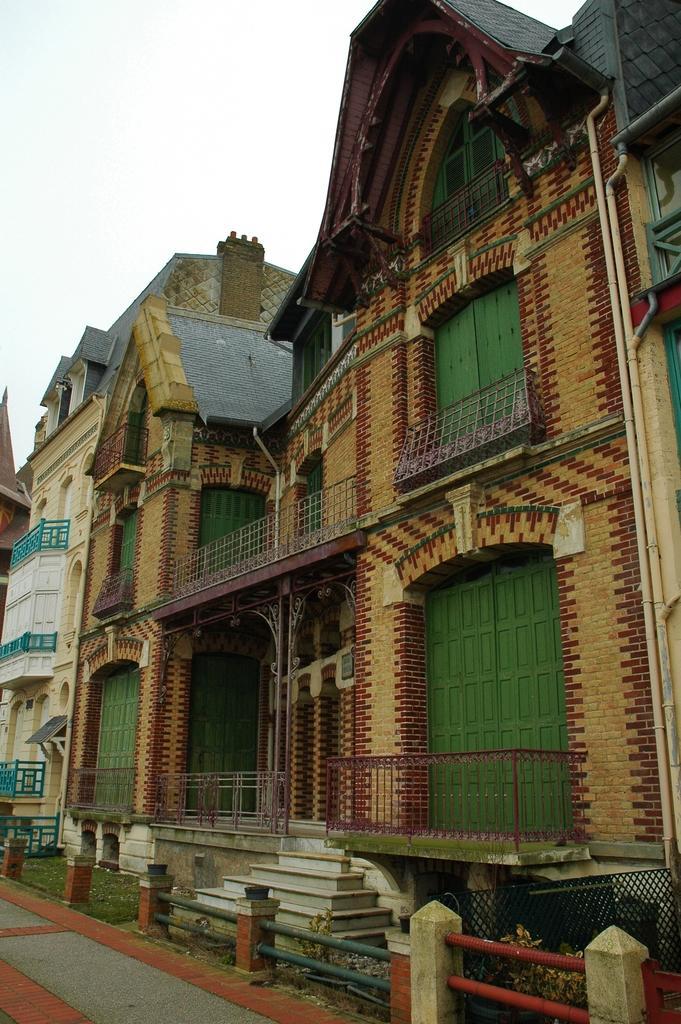How would you summarize this image in a sentence or two? This is an outside view. Here I can see few buildings. In the bottom left there is a road. At the top, I can see the sky. 